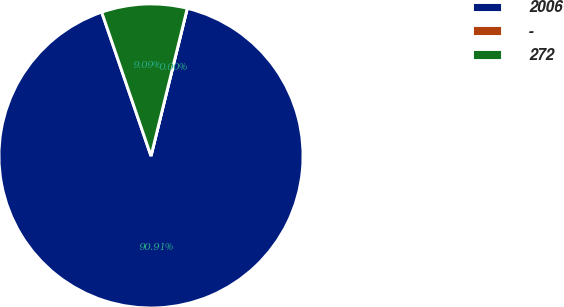Convert chart to OTSL. <chart><loc_0><loc_0><loc_500><loc_500><pie_chart><fcel>2006<fcel>-<fcel>272<nl><fcel>90.9%<fcel>0.0%<fcel>9.09%<nl></chart> 